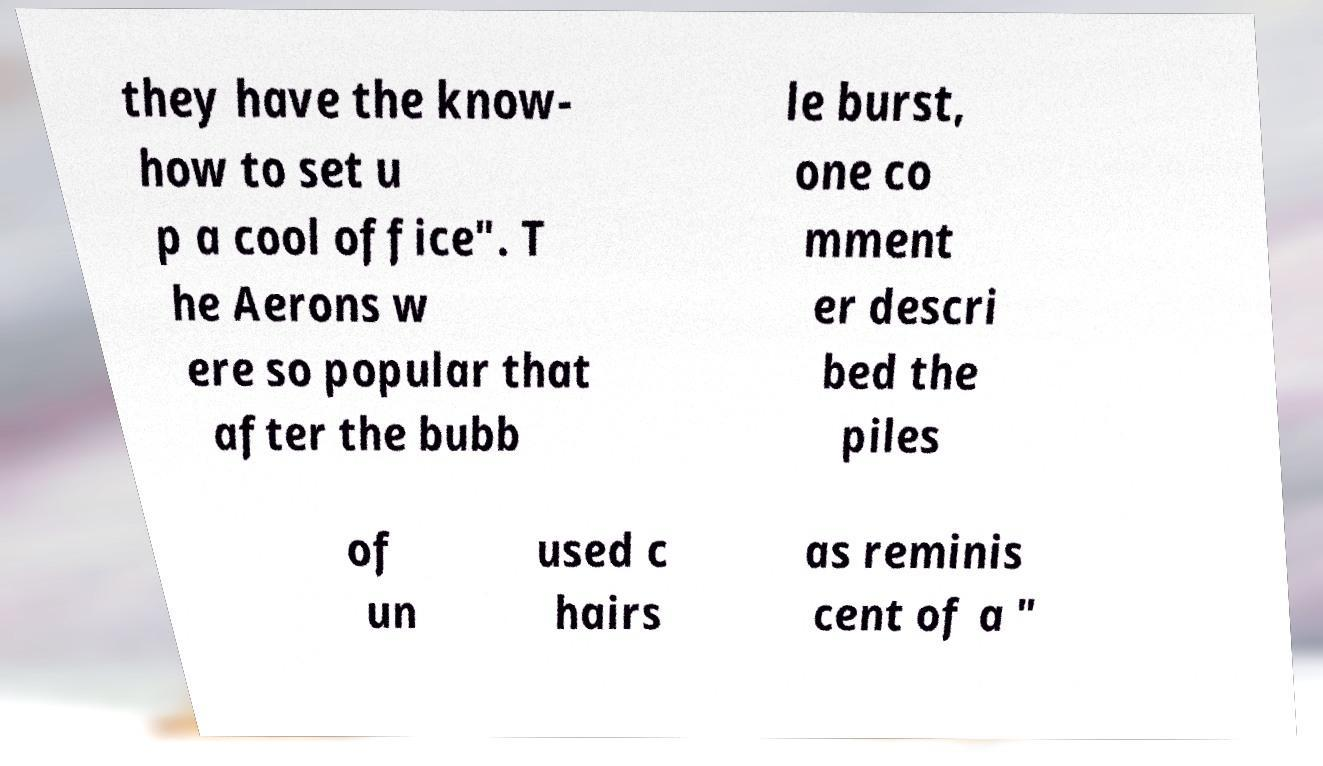Please identify and transcribe the text found in this image. they have the know- how to set u p a cool office". T he Aerons w ere so popular that after the bubb le burst, one co mment er descri bed the piles of un used c hairs as reminis cent of a " 